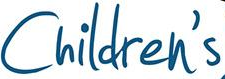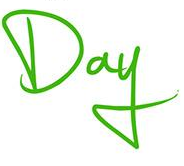What text appears in these images from left to right, separated by a semicolon? Children's; Day 